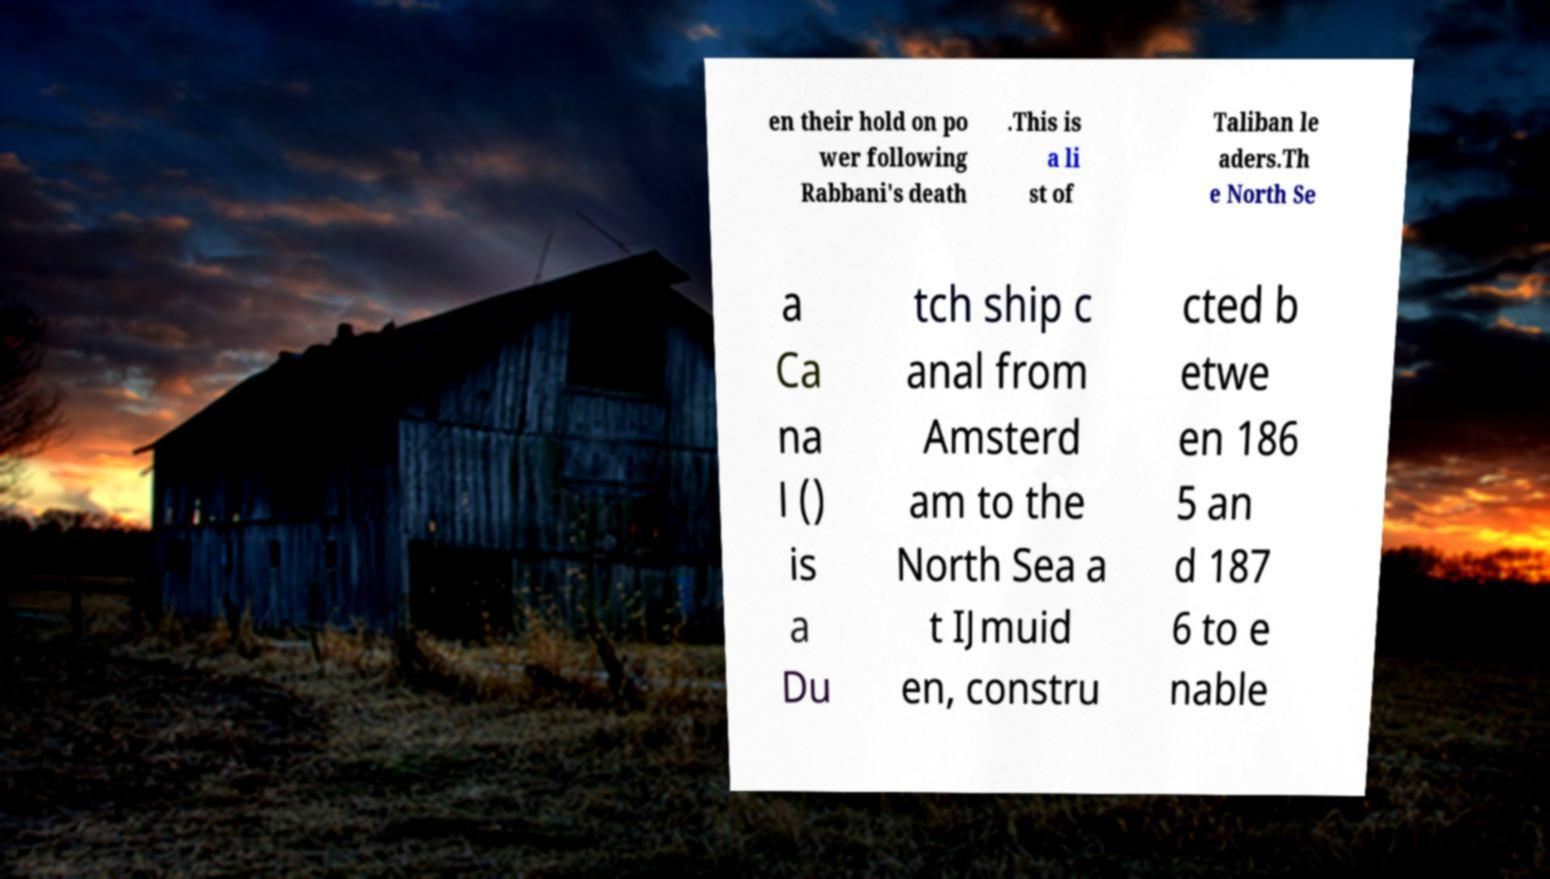There's text embedded in this image that I need extracted. Can you transcribe it verbatim? en their hold on po wer following Rabbani's death .This is a li st of Taliban le aders.Th e North Se a Ca na l () is a Du tch ship c anal from Amsterd am to the North Sea a t IJmuid en, constru cted b etwe en 186 5 an d 187 6 to e nable 